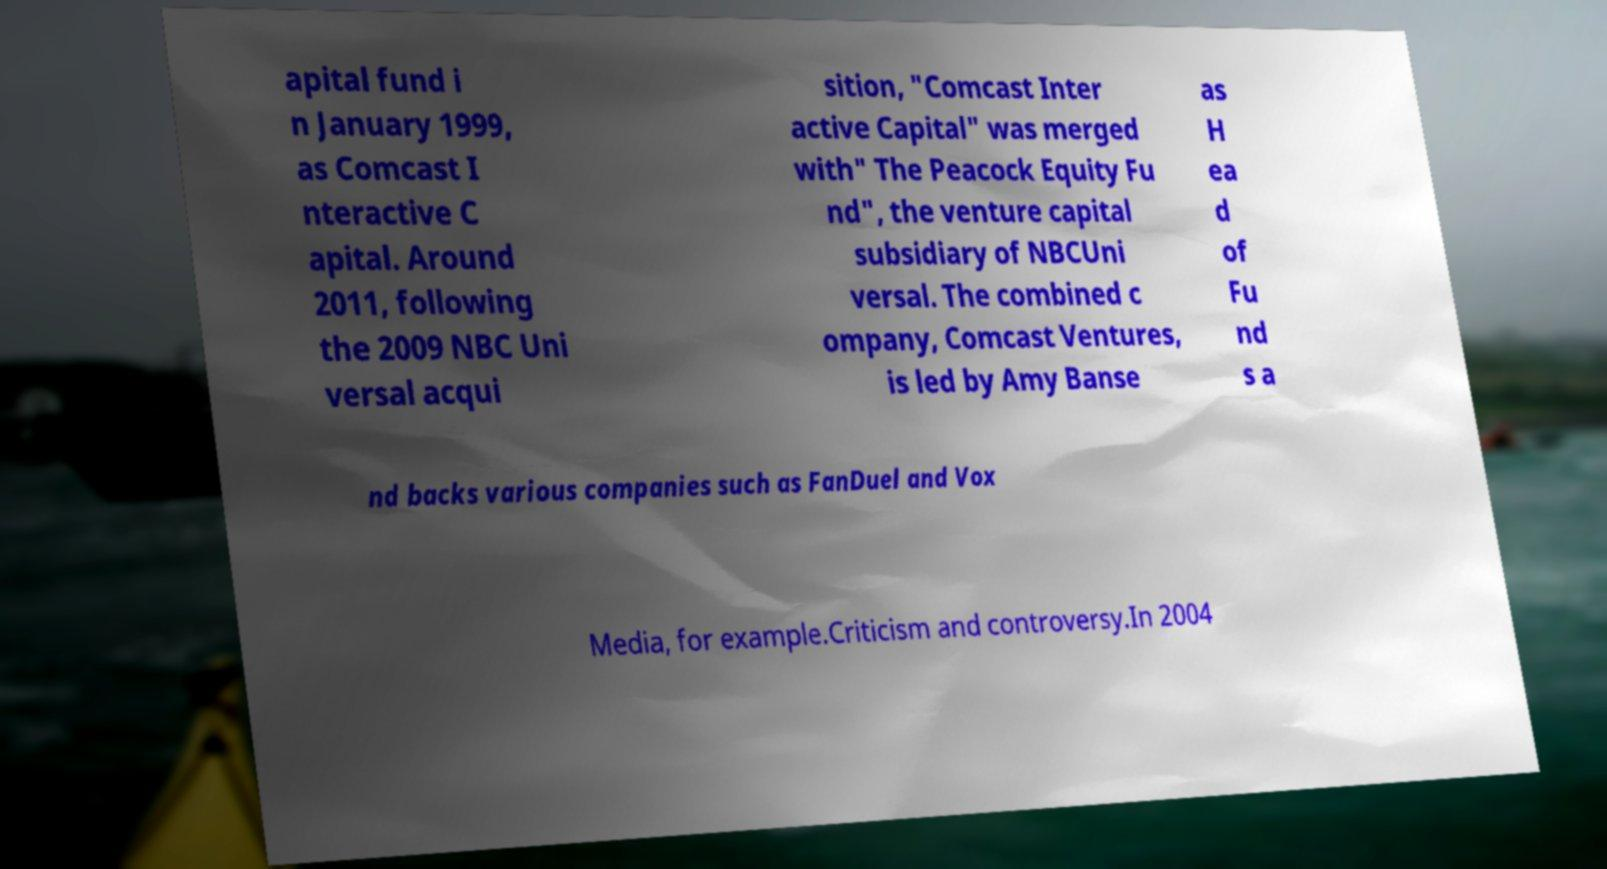I need the written content from this picture converted into text. Can you do that? apital fund i n January 1999, as Comcast I nteractive C apital. Around 2011, following the 2009 NBC Uni versal acqui sition, "Comcast Inter active Capital" was merged with" The Peacock Equity Fu nd", the venture capital subsidiary of NBCUni versal. The combined c ompany, Comcast Ventures, is led by Amy Banse as H ea d of Fu nd s a nd backs various companies such as FanDuel and Vox Media, for example.Criticism and controversy.In 2004 